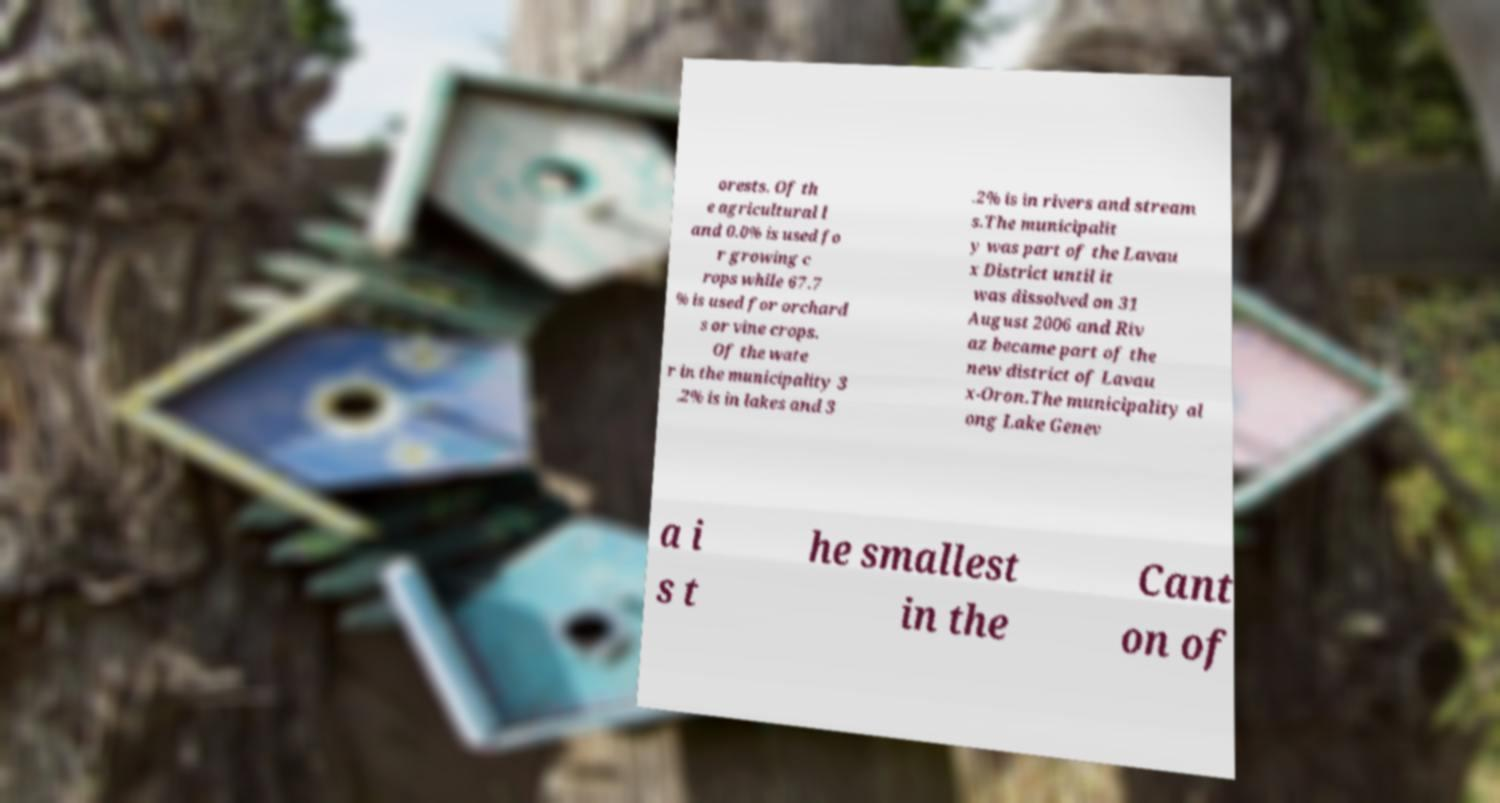Please identify and transcribe the text found in this image. orests. Of th e agricultural l and 0.0% is used fo r growing c rops while 67.7 % is used for orchard s or vine crops. Of the wate r in the municipality 3 .2% is in lakes and 3 .2% is in rivers and stream s.The municipalit y was part of the Lavau x District until it was dissolved on 31 August 2006 and Riv az became part of the new district of Lavau x-Oron.The municipality al ong Lake Genev a i s t he smallest in the Cant on of 